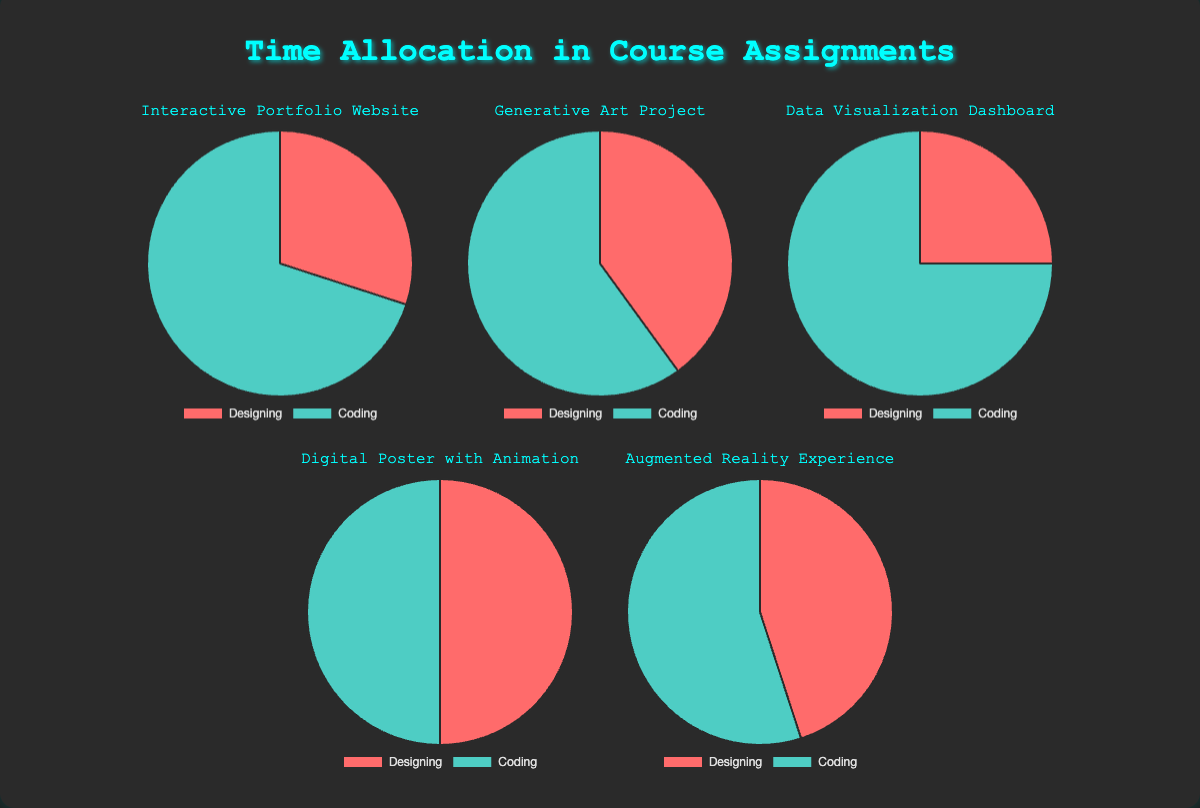Which assignment has the highest time allocation for Coding? The pie charts show the time allocation percentages for Designing and Coding for each assignment. By visually inspecting the charts, the "Data Visualization Dashboard" has the highest time allocation for Coding (75%).
Answer: Data Visualization Dashboard Which assignments have an equal split between Designing and Coding? By looking at the pie charts, the assignment with a 50/50 split between Designing and Coding is the "Digital Poster with Animation".
Answer: Digital Poster with Animation What's the average time allocation for Designing across all assignments? To find the average, sum up the Designing percentages: 30 + 40 + 25 + 50 + 45. The sum is 190. There are 5 assignments, so the average is 190 / 5 = 38%
Answer: 38% Which assignment has the closest Designing allocation to 40%? By inspecting the charts, the "Generative Art Project" has a Designing allocation of 40%, which matches the query.
Answer: Generative Art Project How does the time allocation for Coding in the "Interactive Portfolio Website" compare to the "Augmented Reality Experience"? The Coding allocation for "Interactive Portfolio Website" is 70%, while for "Augmented Reality Experience" it is 55%. Therefore, the "Interactive Portfolio Website" has more time allocated to Coding.
Answer: Interactive Portfolio Website has more What is the total time allocation for Coding across all assignments? Sum up the Coding percentages: 70 + 60 + 75 + 50 + 55. The sum is 310%.
Answer: 310% Is the time allocation for Designing greater than the time allocation for Coding in any assignment? By inspecting the pie charts, none of the assignments have a higher Designing allocation than Coding.
Answer: No Which assignment dedicates the most time to Designing? By looking at the pie charts, the "Digital Poster with Animation" dedicates the most time to Designing with 50%.
Answer: Digital Poster with Animation For how many assignments does the Coding time allocation exceed 60%? By inspecting the pie charts, three assignments have a Coding time allocation exceeding 60%: "Interactive Portfolio Website" (70%), "Generative Art Project" (60%), and "Data Visualization Dashboard" (75%).
Answer: 3 Comparing the "Interactive Portfolio Website" and the "Data Visualization Dashboard", which has a higher proportion of Designing? By inspecting the charts, the "Interactive Portfolio Website" has 30% for Designing, and the "Data Visualization Dashboard" has 25%. So, the "Interactive Portfolio Website" has a higher Designing proportion.
Answer: Interactive Portfolio Website 